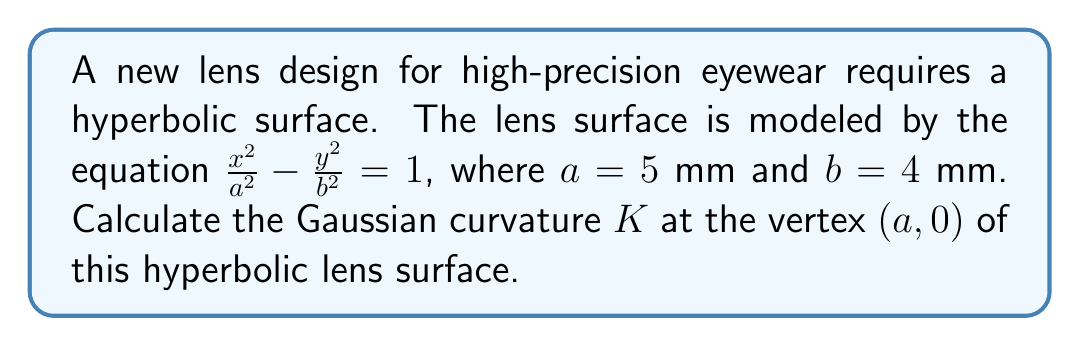Can you solve this math problem? To calculate the Gaussian curvature $K$ at the vertex of a hyperbolic surface, we'll follow these steps:

1) The general equation for a hyperbola is $\frac{x^2}{a^2} - \frac{y^2}{b^2} = 1$.

2) The Gaussian curvature $K$ for a surface of revolution generated by a curve $y=f(x)$ is given by:

   $$K = -\frac{f''(x)}{f(x)[1+(f'(x))^2]^2}$$

3) For our hyperbola, we can express $y$ as a function of $x$:

   $$y = \pm b\sqrt{\frac{x^2}{a^2} - 1}$$

4) We need to calculate $f(x)$, $f'(x)$, and $f''(x)$:

   $$f(x) = b\sqrt{\frac{x^2}{a^2} - 1}$$
   
   $$f'(x) = \frac{bx}{a^2\sqrt{\frac{x^2}{a^2} - 1}}$$
   
   $$f''(x) = \frac{b}{a^2\sqrt{\frac{x^2}{a^2} - 1}} - \frac{bx^2}{a^2(\frac{x^2}{a^2} - 1)^{3/2}}$$

5) At the vertex $(a,0)$, $x = a = 5$ mm. Substituting this:

   $$f(a) = 0$$
   
   $$f'(a) = \frac{b}{a} = \frac{4}{5}$$
   
   $$f''(a) = \frac{b}{a^2} = \frac{4}{25}$$

6) Now we can calculate $K$:

   $$K = -\frac{f''(a)}{f(a)[1+(f'(a))^2]^2}$$

   $$K = -\frac{\frac{4}{25}}{0[1+(\frac{4}{5})^2]^2}$$

7) Since $f(a) = 0$, we get:

   $$K = -\infty$$

This infinite negative curvature is characteristic of the vertex of a hyperbola.
Answer: $K = -\infty$ 